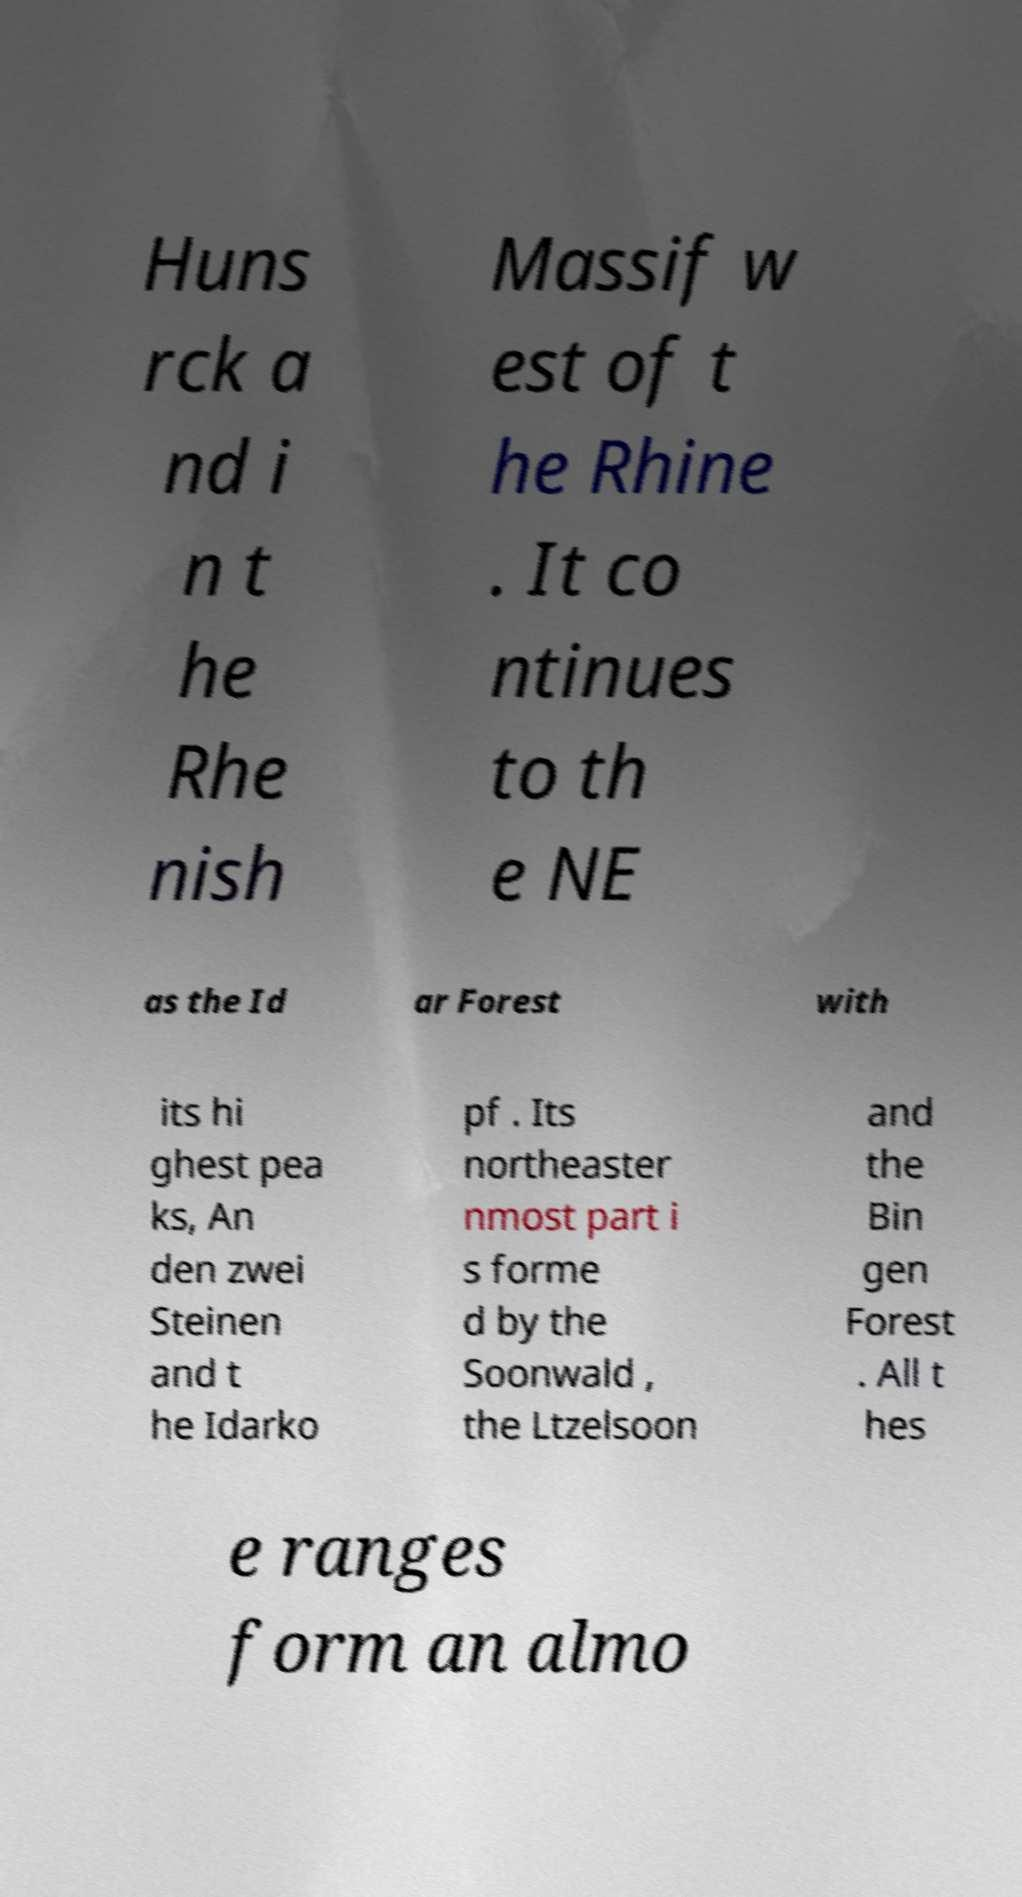I need the written content from this picture converted into text. Can you do that? Huns rck a nd i n t he Rhe nish Massif w est of t he Rhine . It co ntinues to th e NE as the Id ar Forest with its hi ghest pea ks, An den zwei Steinen and t he Idarko pf . Its northeaster nmost part i s forme d by the Soonwald , the Ltzelsoon and the Bin gen Forest . All t hes e ranges form an almo 